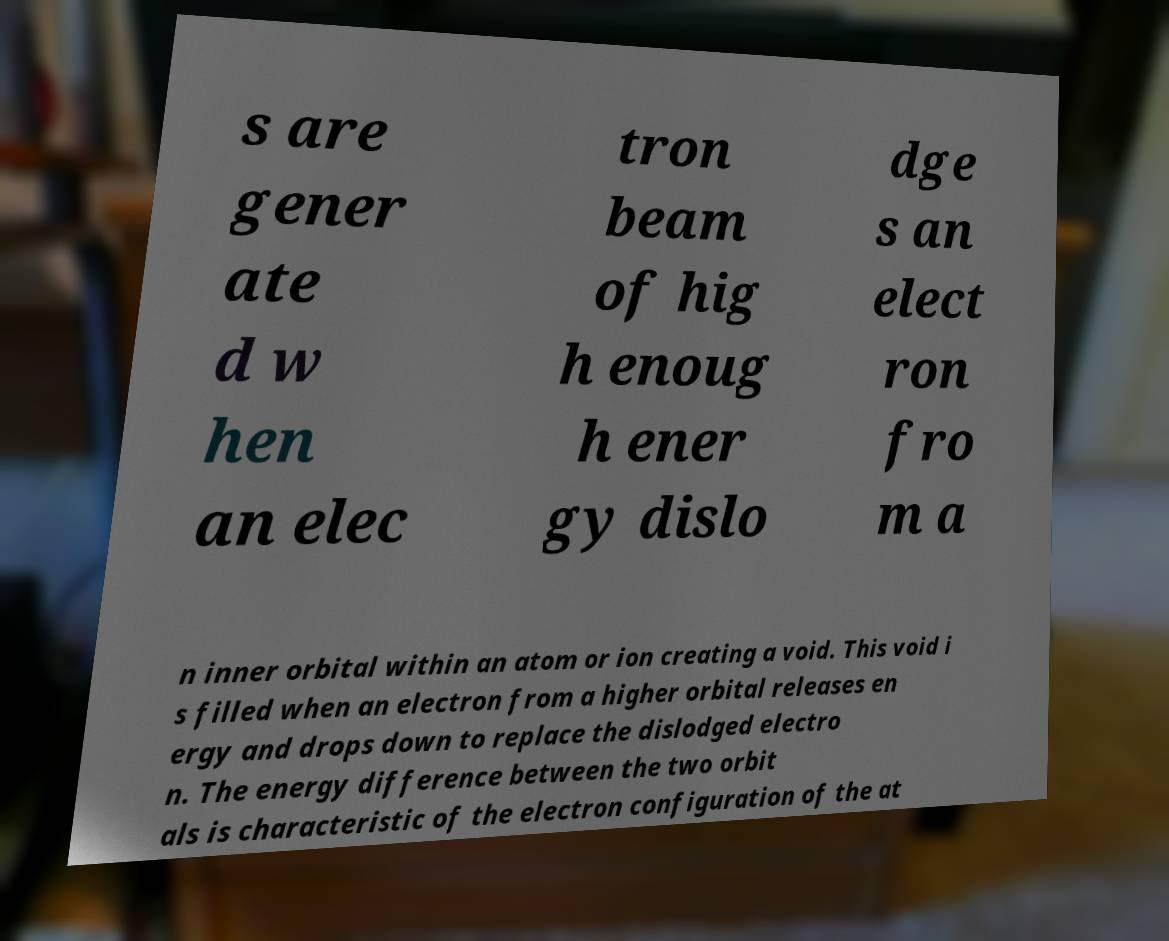There's text embedded in this image that I need extracted. Can you transcribe it verbatim? s are gener ate d w hen an elec tron beam of hig h enoug h ener gy dislo dge s an elect ron fro m a n inner orbital within an atom or ion creating a void. This void i s filled when an electron from a higher orbital releases en ergy and drops down to replace the dislodged electro n. The energy difference between the two orbit als is characteristic of the electron configuration of the at 